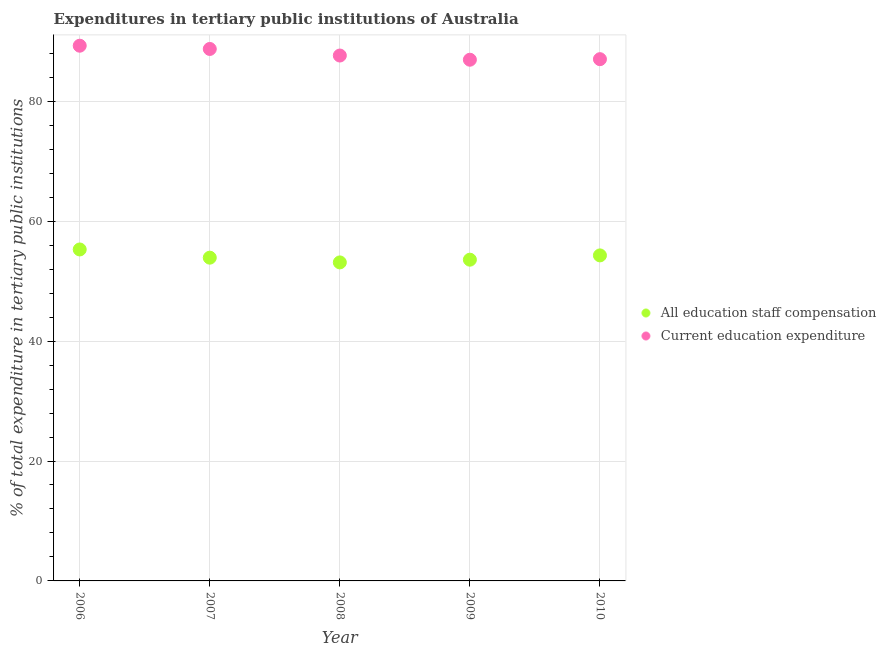Is the number of dotlines equal to the number of legend labels?
Give a very brief answer. Yes. What is the expenditure in education in 2010?
Offer a very short reply. 87.02. Across all years, what is the maximum expenditure in education?
Offer a terse response. 89.27. Across all years, what is the minimum expenditure in education?
Offer a very short reply. 86.93. In which year was the expenditure in staff compensation maximum?
Offer a very short reply. 2006. In which year was the expenditure in education minimum?
Your response must be concise. 2009. What is the total expenditure in staff compensation in the graph?
Offer a very short reply. 270.2. What is the difference between the expenditure in education in 2006 and that in 2007?
Provide a succinct answer. 0.54. What is the difference between the expenditure in education in 2006 and the expenditure in staff compensation in 2009?
Offer a very short reply. 35.69. What is the average expenditure in education per year?
Provide a short and direct response. 87.91. In the year 2009, what is the difference between the expenditure in staff compensation and expenditure in education?
Provide a succinct answer. -33.35. What is the ratio of the expenditure in education in 2008 to that in 2009?
Provide a succinct answer. 1.01. Is the difference between the expenditure in education in 2008 and 2009 greater than the difference between the expenditure in staff compensation in 2008 and 2009?
Give a very brief answer. Yes. What is the difference between the highest and the second highest expenditure in staff compensation?
Make the answer very short. 0.99. What is the difference between the highest and the lowest expenditure in education?
Keep it short and to the point. 2.34. In how many years, is the expenditure in education greater than the average expenditure in education taken over all years?
Provide a succinct answer. 2. Is the sum of the expenditure in staff compensation in 2006 and 2007 greater than the maximum expenditure in education across all years?
Ensure brevity in your answer.  Yes. Does the expenditure in education monotonically increase over the years?
Your response must be concise. No. Is the expenditure in staff compensation strictly less than the expenditure in education over the years?
Provide a short and direct response. Yes. What is the difference between two consecutive major ticks on the Y-axis?
Offer a terse response. 20. Are the values on the major ticks of Y-axis written in scientific E-notation?
Keep it short and to the point. No. Does the graph contain any zero values?
Give a very brief answer. No. Does the graph contain grids?
Keep it short and to the point. Yes. Where does the legend appear in the graph?
Your response must be concise. Center right. How are the legend labels stacked?
Provide a succinct answer. Vertical. What is the title of the graph?
Offer a very short reply. Expenditures in tertiary public institutions of Australia. What is the label or title of the X-axis?
Provide a succinct answer. Year. What is the label or title of the Y-axis?
Your answer should be very brief. % of total expenditure in tertiary public institutions. What is the % of total expenditure in tertiary public institutions of All education staff compensation in 2006?
Offer a very short reply. 55.28. What is the % of total expenditure in tertiary public institutions in Current education expenditure in 2006?
Provide a short and direct response. 89.27. What is the % of total expenditure in tertiary public institutions of All education staff compensation in 2007?
Make the answer very short. 53.91. What is the % of total expenditure in tertiary public institutions in Current education expenditure in 2007?
Your answer should be compact. 88.73. What is the % of total expenditure in tertiary public institutions in All education staff compensation in 2008?
Make the answer very short. 53.12. What is the % of total expenditure in tertiary public institutions of Current education expenditure in 2008?
Offer a very short reply. 87.63. What is the % of total expenditure in tertiary public institutions of All education staff compensation in 2009?
Ensure brevity in your answer.  53.58. What is the % of total expenditure in tertiary public institutions in Current education expenditure in 2009?
Offer a terse response. 86.93. What is the % of total expenditure in tertiary public institutions of All education staff compensation in 2010?
Ensure brevity in your answer.  54.29. What is the % of total expenditure in tertiary public institutions of Current education expenditure in 2010?
Provide a succinct answer. 87.02. Across all years, what is the maximum % of total expenditure in tertiary public institutions of All education staff compensation?
Provide a short and direct response. 55.28. Across all years, what is the maximum % of total expenditure in tertiary public institutions of Current education expenditure?
Provide a short and direct response. 89.27. Across all years, what is the minimum % of total expenditure in tertiary public institutions in All education staff compensation?
Ensure brevity in your answer.  53.12. Across all years, what is the minimum % of total expenditure in tertiary public institutions in Current education expenditure?
Give a very brief answer. 86.93. What is the total % of total expenditure in tertiary public institutions in All education staff compensation in the graph?
Your answer should be compact. 270.2. What is the total % of total expenditure in tertiary public institutions of Current education expenditure in the graph?
Your answer should be very brief. 439.57. What is the difference between the % of total expenditure in tertiary public institutions of All education staff compensation in 2006 and that in 2007?
Provide a short and direct response. 1.37. What is the difference between the % of total expenditure in tertiary public institutions of Current education expenditure in 2006 and that in 2007?
Keep it short and to the point. 0.54. What is the difference between the % of total expenditure in tertiary public institutions in All education staff compensation in 2006 and that in 2008?
Ensure brevity in your answer.  2.16. What is the difference between the % of total expenditure in tertiary public institutions in Current education expenditure in 2006 and that in 2008?
Make the answer very short. 1.64. What is the difference between the % of total expenditure in tertiary public institutions of All education staff compensation in 2006 and that in 2009?
Your response must be concise. 1.7. What is the difference between the % of total expenditure in tertiary public institutions in Current education expenditure in 2006 and that in 2009?
Ensure brevity in your answer.  2.34. What is the difference between the % of total expenditure in tertiary public institutions of All education staff compensation in 2006 and that in 2010?
Provide a short and direct response. 0.99. What is the difference between the % of total expenditure in tertiary public institutions in Current education expenditure in 2006 and that in 2010?
Ensure brevity in your answer.  2.24. What is the difference between the % of total expenditure in tertiary public institutions in All education staff compensation in 2007 and that in 2008?
Offer a very short reply. 0.79. What is the difference between the % of total expenditure in tertiary public institutions of Current education expenditure in 2007 and that in 2008?
Offer a terse response. 1.1. What is the difference between the % of total expenditure in tertiary public institutions of All education staff compensation in 2007 and that in 2009?
Your answer should be very brief. 0.34. What is the difference between the % of total expenditure in tertiary public institutions of Current education expenditure in 2007 and that in 2009?
Provide a short and direct response. 1.8. What is the difference between the % of total expenditure in tertiary public institutions of All education staff compensation in 2007 and that in 2010?
Your answer should be compact. -0.38. What is the difference between the % of total expenditure in tertiary public institutions of Current education expenditure in 2007 and that in 2010?
Provide a short and direct response. 1.7. What is the difference between the % of total expenditure in tertiary public institutions in All education staff compensation in 2008 and that in 2009?
Your response must be concise. -0.45. What is the difference between the % of total expenditure in tertiary public institutions in Current education expenditure in 2008 and that in 2009?
Keep it short and to the point. 0.7. What is the difference between the % of total expenditure in tertiary public institutions of All education staff compensation in 2008 and that in 2010?
Your answer should be compact. -1.17. What is the difference between the % of total expenditure in tertiary public institutions of Current education expenditure in 2008 and that in 2010?
Give a very brief answer. 0.61. What is the difference between the % of total expenditure in tertiary public institutions in All education staff compensation in 2009 and that in 2010?
Your answer should be very brief. -0.71. What is the difference between the % of total expenditure in tertiary public institutions of Current education expenditure in 2009 and that in 2010?
Offer a very short reply. -0.09. What is the difference between the % of total expenditure in tertiary public institutions of All education staff compensation in 2006 and the % of total expenditure in tertiary public institutions of Current education expenditure in 2007?
Your response must be concise. -33.44. What is the difference between the % of total expenditure in tertiary public institutions of All education staff compensation in 2006 and the % of total expenditure in tertiary public institutions of Current education expenditure in 2008?
Your answer should be compact. -32.34. What is the difference between the % of total expenditure in tertiary public institutions of All education staff compensation in 2006 and the % of total expenditure in tertiary public institutions of Current education expenditure in 2009?
Ensure brevity in your answer.  -31.65. What is the difference between the % of total expenditure in tertiary public institutions in All education staff compensation in 2006 and the % of total expenditure in tertiary public institutions in Current education expenditure in 2010?
Give a very brief answer. -31.74. What is the difference between the % of total expenditure in tertiary public institutions in All education staff compensation in 2007 and the % of total expenditure in tertiary public institutions in Current education expenditure in 2008?
Provide a short and direct response. -33.71. What is the difference between the % of total expenditure in tertiary public institutions of All education staff compensation in 2007 and the % of total expenditure in tertiary public institutions of Current education expenditure in 2009?
Your answer should be compact. -33.01. What is the difference between the % of total expenditure in tertiary public institutions in All education staff compensation in 2007 and the % of total expenditure in tertiary public institutions in Current education expenditure in 2010?
Your answer should be very brief. -33.11. What is the difference between the % of total expenditure in tertiary public institutions in All education staff compensation in 2008 and the % of total expenditure in tertiary public institutions in Current education expenditure in 2009?
Keep it short and to the point. -33.8. What is the difference between the % of total expenditure in tertiary public institutions of All education staff compensation in 2008 and the % of total expenditure in tertiary public institutions of Current education expenditure in 2010?
Make the answer very short. -33.9. What is the difference between the % of total expenditure in tertiary public institutions in All education staff compensation in 2009 and the % of total expenditure in tertiary public institutions in Current education expenditure in 2010?
Your answer should be compact. -33.44. What is the average % of total expenditure in tertiary public institutions in All education staff compensation per year?
Provide a succinct answer. 54.04. What is the average % of total expenditure in tertiary public institutions in Current education expenditure per year?
Ensure brevity in your answer.  87.91. In the year 2006, what is the difference between the % of total expenditure in tertiary public institutions in All education staff compensation and % of total expenditure in tertiary public institutions in Current education expenditure?
Your answer should be compact. -33.98. In the year 2007, what is the difference between the % of total expenditure in tertiary public institutions of All education staff compensation and % of total expenditure in tertiary public institutions of Current education expenditure?
Provide a short and direct response. -34.81. In the year 2008, what is the difference between the % of total expenditure in tertiary public institutions of All education staff compensation and % of total expenditure in tertiary public institutions of Current education expenditure?
Your answer should be compact. -34.5. In the year 2009, what is the difference between the % of total expenditure in tertiary public institutions in All education staff compensation and % of total expenditure in tertiary public institutions in Current education expenditure?
Provide a short and direct response. -33.35. In the year 2010, what is the difference between the % of total expenditure in tertiary public institutions in All education staff compensation and % of total expenditure in tertiary public institutions in Current education expenditure?
Give a very brief answer. -32.73. What is the ratio of the % of total expenditure in tertiary public institutions of All education staff compensation in 2006 to that in 2007?
Give a very brief answer. 1.03. What is the ratio of the % of total expenditure in tertiary public institutions of All education staff compensation in 2006 to that in 2008?
Give a very brief answer. 1.04. What is the ratio of the % of total expenditure in tertiary public institutions of Current education expenditure in 2006 to that in 2008?
Your answer should be compact. 1.02. What is the ratio of the % of total expenditure in tertiary public institutions of All education staff compensation in 2006 to that in 2009?
Provide a succinct answer. 1.03. What is the ratio of the % of total expenditure in tertiary public institutions in Current education expenditure in 2006 to that in 2009?
Make the answer very short. 1.03. What is the ratio of the % of total expenditure in tertiary public institutions in All education staff compensation in 2006 to that in 2010?
Give a very brief answer. 1.02. What is the ratio of the % of total expenditure in tertiary public institutions of Current education expenditure in 2006 to that in 2010?
Keep it short and to the point. 1.03. What is the ratio of the % of total expenditure in tertiary public institutions of All education staff compensation in 2007 to that in 2008?
Keep it short and to the point. 1.01. What is the ratio of the % of total expenditure in tertiary public institutions in Current education expenditure in 2007 to that in 2008?
Keep it short and to the point. 1.01. What is the ratio of the % of total expenditure in tertiary public institutions in Current education expenditure in 2007 to that in 2009?
Your answer should be compact. 1.02. What is the ratio of the % of total expenditure in tertiary public institutions of Current education expenditure in 2007 to that in 2010?
Ensure brevity in your answer.  1.02. What is the ratio of the % of total expenditure in tertiary public institutions of All education staff compensation in 2008 to that in 2009?
Keep it short and to the point. 0.99. What is the ratio of the % of total expenditure in tertiary public institutions of Current education expenditure in 2008 to that in 2009?
Your answer should be compact. 1.01. What is the ratio of the % of total expenditure in tertiary public institutions in All education staff compensation in 2008 to that in 2010?
Your answer should be compact. 0.98. What is the difference between the highest and the second highest % of total expenditure in tertiary public institutions in All education staff compensation?
Offer a very short reply. 0.99. What is the difference between the highest and the second highest % of total expenditure in tertiary public institutions in Current education expenditure?
Your response must be concise. 0.54. What is the difference between the highest and the lowest % of total expenditure in tertiary public institutions in All education staff compensation?
Your response must be concise. 2.16. What is the difference between the highest and the lowest % of total expenditure in tertiary public institutions of Current education expenditure?
Offer a very short reply. 2.34. 